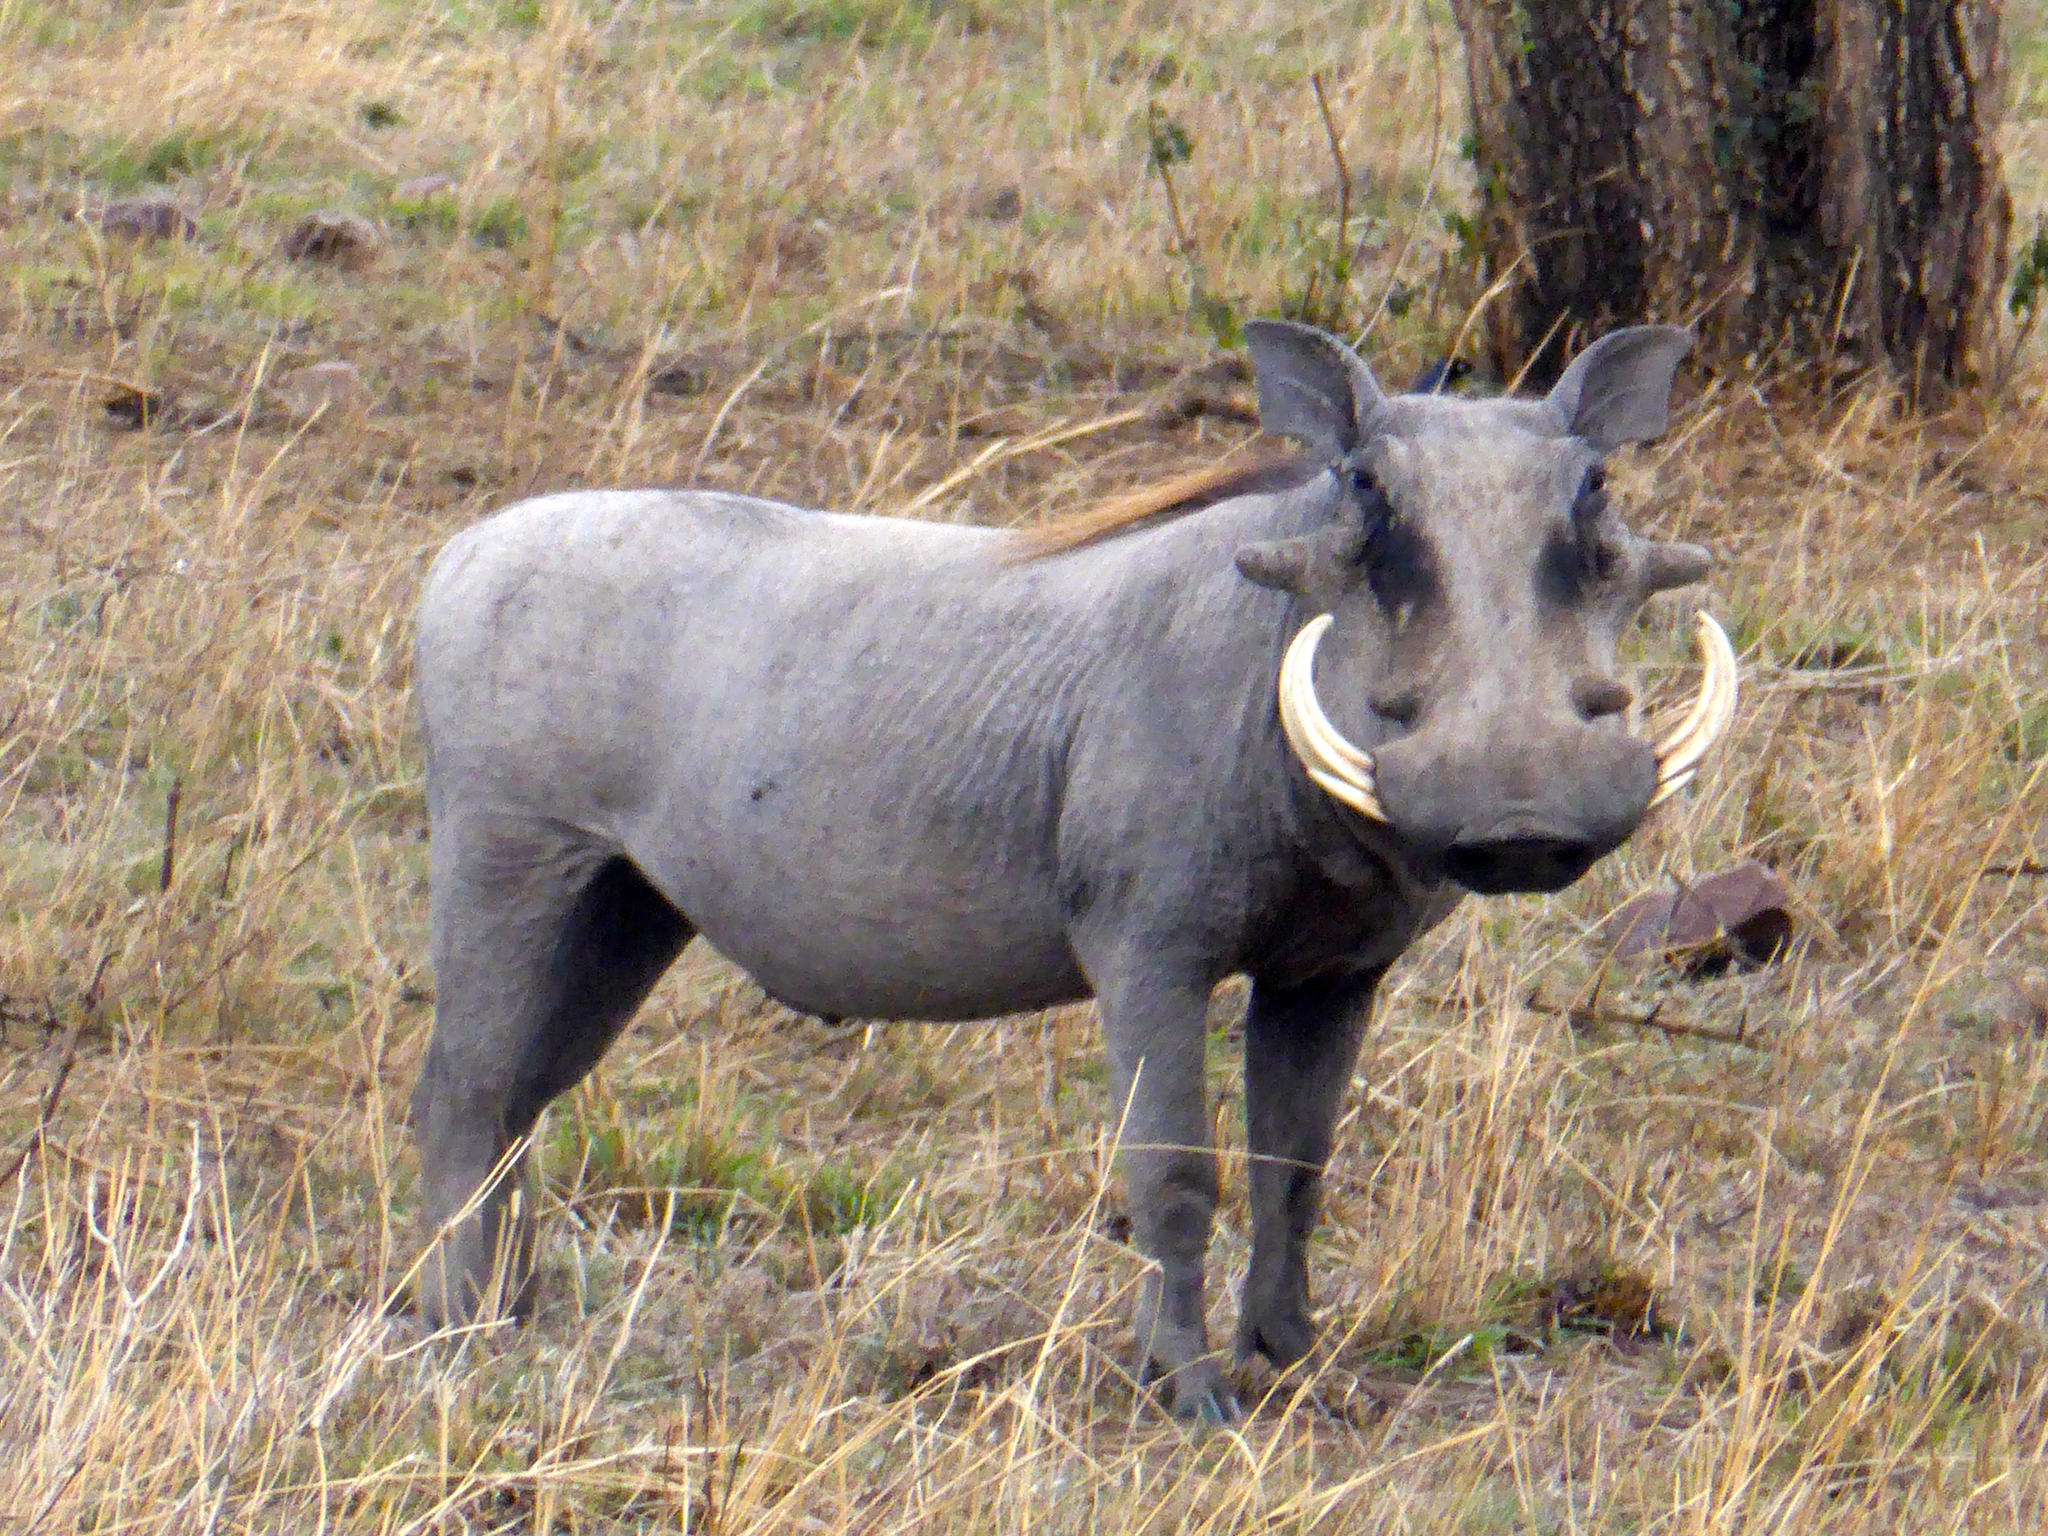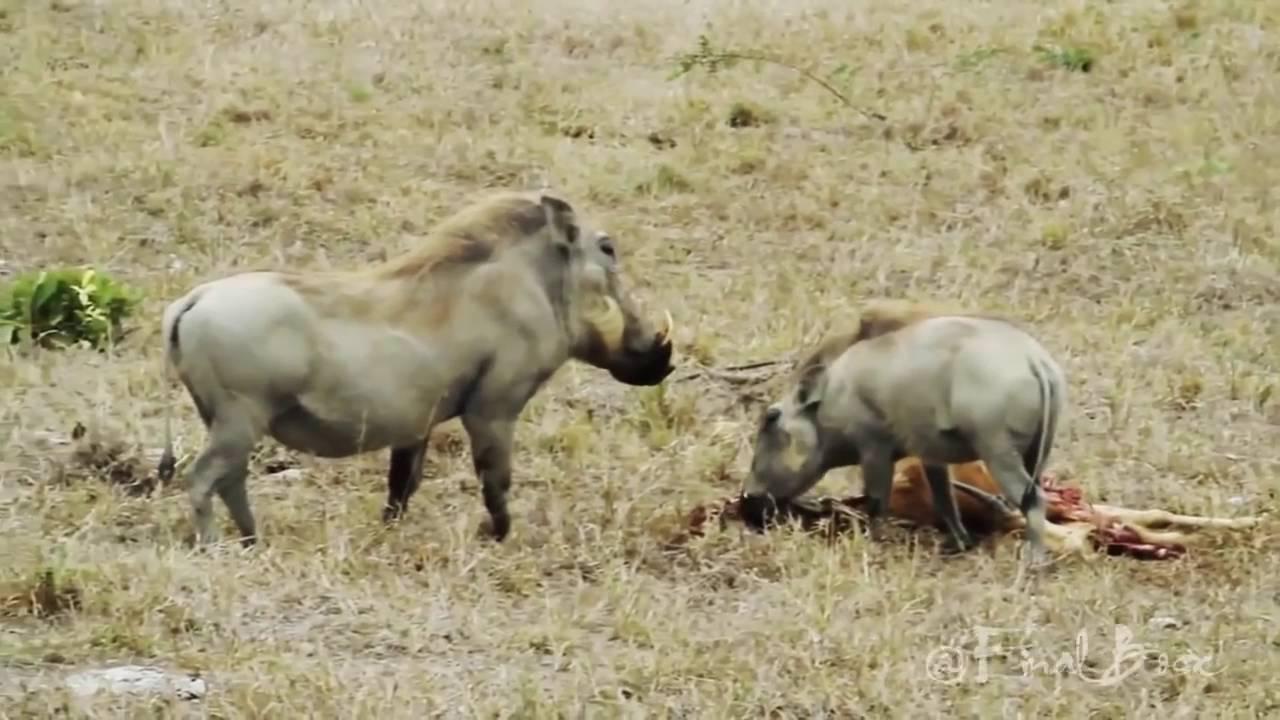The first image is the image on the left, the second image is the image on the right. Assess this claim about the two images: "There are at least 4 animals.". Correct or not? Answer yes or no. No. The first image is the image on the left, the second image is the image on the right. Assess this claim about the two images: "All of the wild boars are alive and at least one other type of animal is also alive.". Correct or not? Answer yes or no. No. 